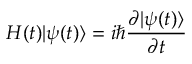Convert formula to latex. <formula><loc_0><loc_0><loc_500><loc_500>H ( t ) | \psi ( t ) \rangle = i \hbar { \frac { \partial | \psi ( t ) \rangle } { \partial t } }</formula> 